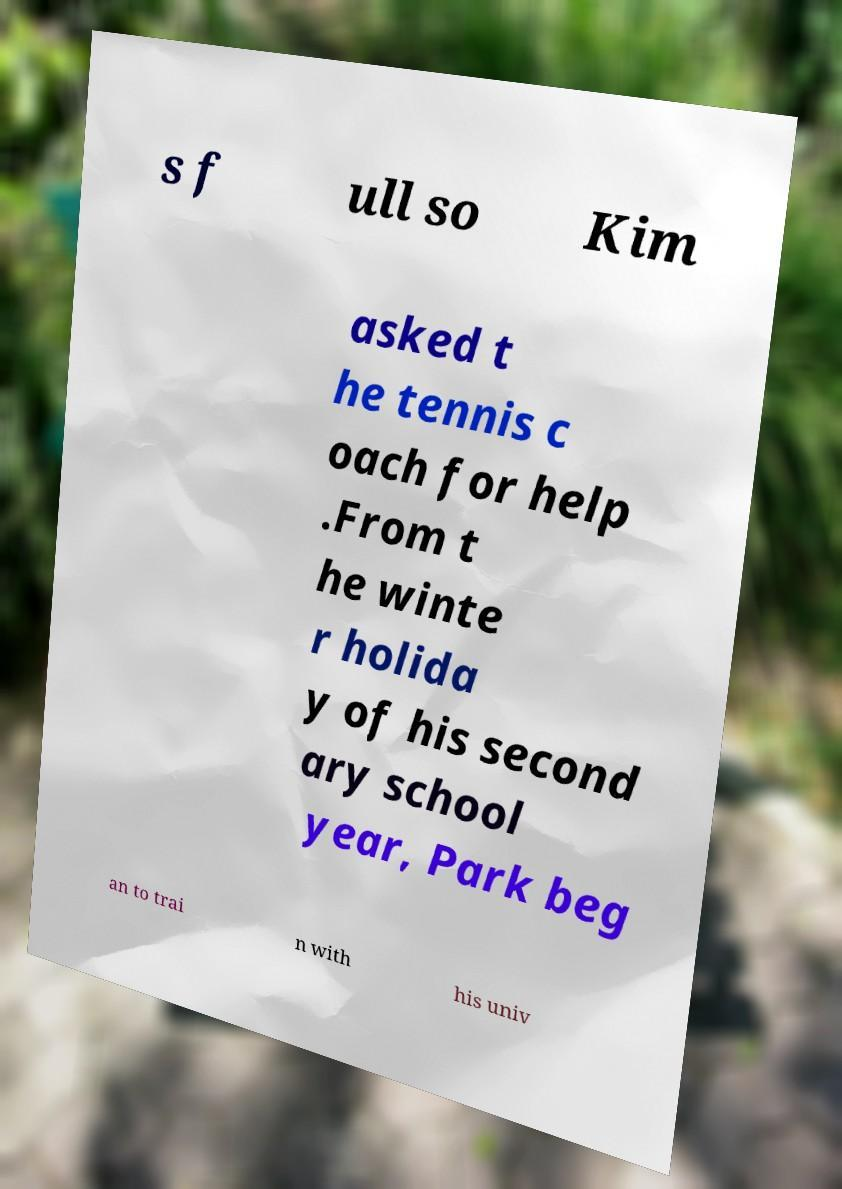There's text embedded in this image that I need extracted. Can you transcribe it verbatim? s f ull so Kim asked t he tennis c oach for help .From t he winte r holida y of his second ary school year, Park beg an to trai n with his univ 